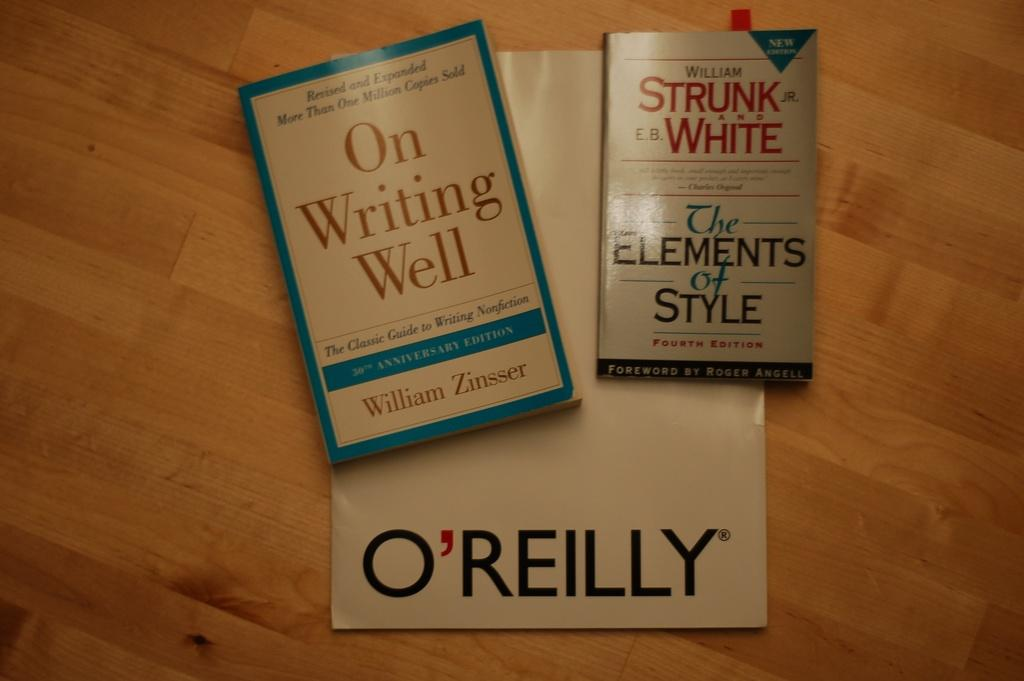<image>
Provide a brief description of the given image. The book on the left is blue and titled "On Writing Well". 